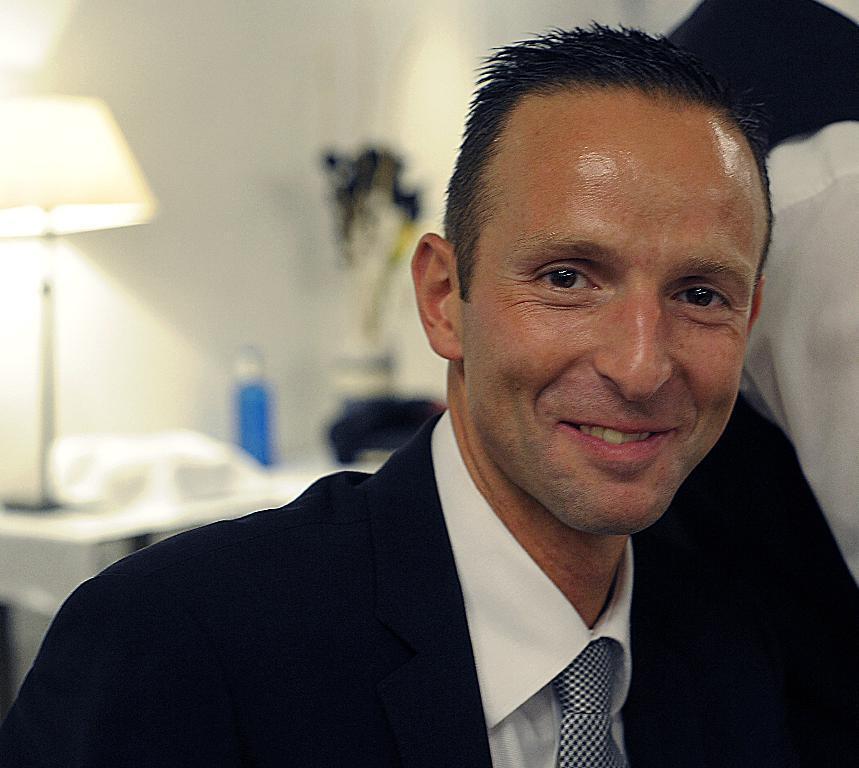Can you describe this image briefly? Here I can see a man wearing black color suit, smiling and giving pose for the picture. On the right side there is another person. In the background there is a table on which a lamp, bottle and some other objects are placed. At the back there is a wall. 